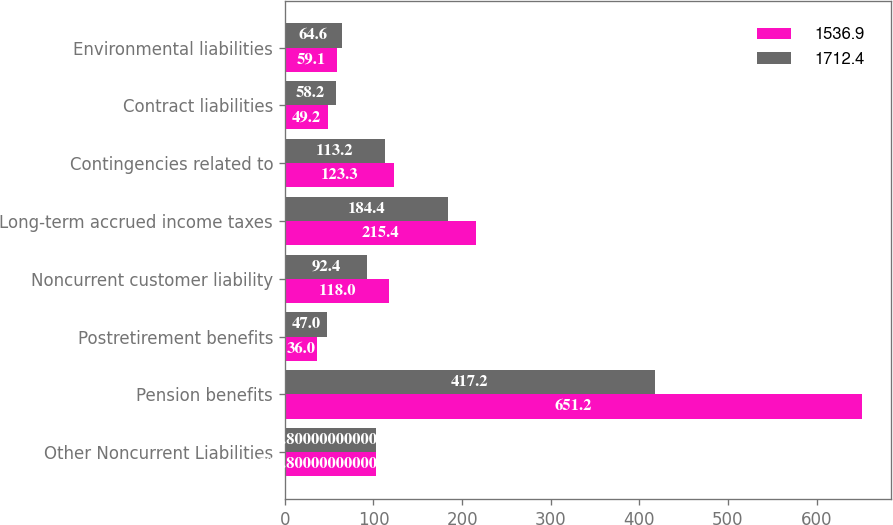<chart> <loc_0><loc_0><loc_500><loc_500><stacked_bar_chart><ecel><fcel>Other Noncurrent Liabilities<fcel>Pension benefits<fcel>Postretirement benefits<fcel>Noncurrent customer liability<fcel>Long-term accrued income taxes<fcel>Contingencies related to<fcel>Contract liabilities<fcel>Environmental liabilities<nl><fcel>1536.9<fcel>102.8<fcel>651.2<fcel>36<fcel>118<fcel>215.4<fcel>123.3<fcel>49.2<fcel>59.1<nl><fcel>1712.4<fcel>102.8<fcel>417.2<fcel>47<fcel>92.4<fcel>184.4<fcel>113.2<fcel>58.2<fcel>64.6<nl></chart> 